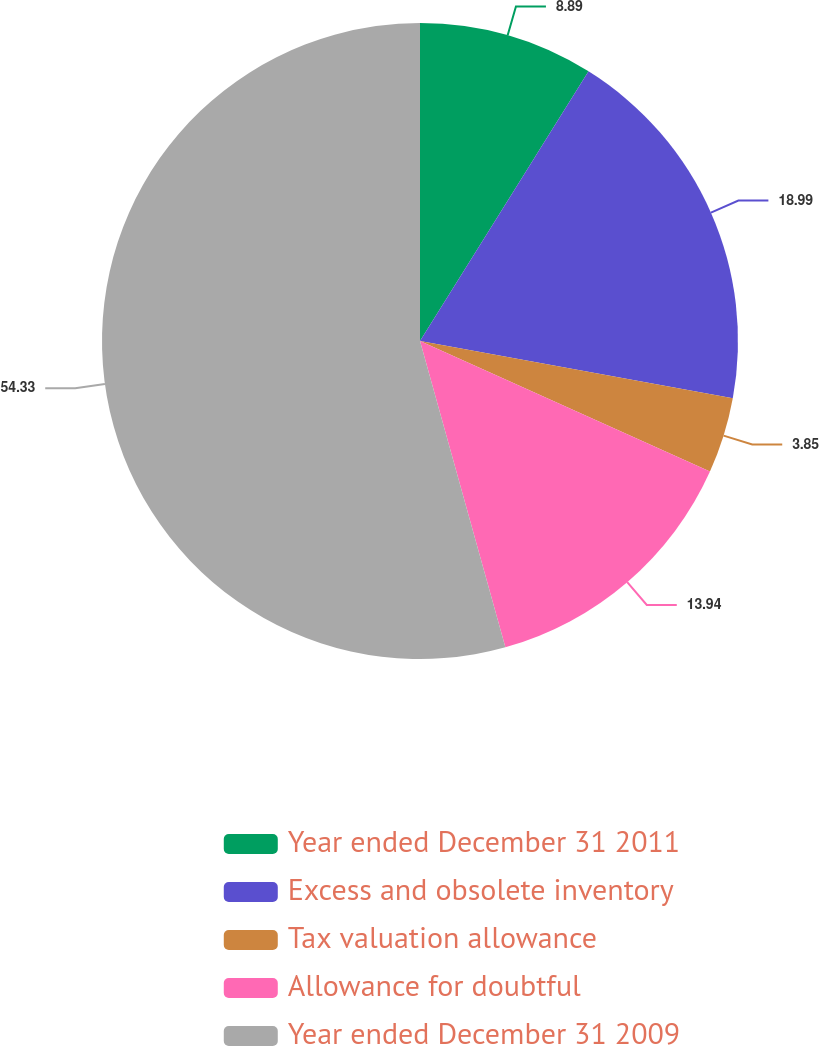<chart> <loc_0><loc_0><loc_500><loc_500><pie_chart><fcel>Year ended December 31 2011<fcel>Excess and obsolete inventory<fcel>Tax valuation allowance<fcel>Allowance for doubtful<fcel>Year ended December 31 2009<nl><fcel>8.89%<fcel>18.99%<fcel>3.85%<fcel>13.94%<fcel>54.32%<nl></chart> 